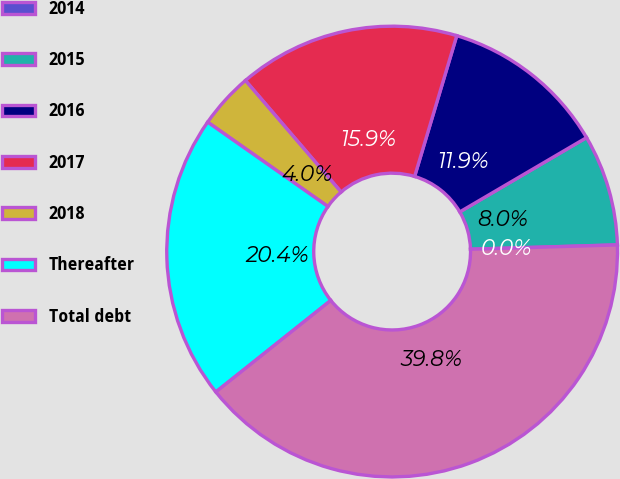Convert chart to OTSL. <chart><loc_0><loc_0><loc_500><loc_500><pie_chart><fcel>2014<fcel>2015<fcel>2016<fcel>2017<fcel>2018<fcel>Thereafter<fcel>Total debt<nl><fcel>0.01%<fcel>7.96%<fcel>11.93%<fcel>15.91%<fcel>3.98%<fcel>20.44%<fcel>39.76%<nl></chart> 